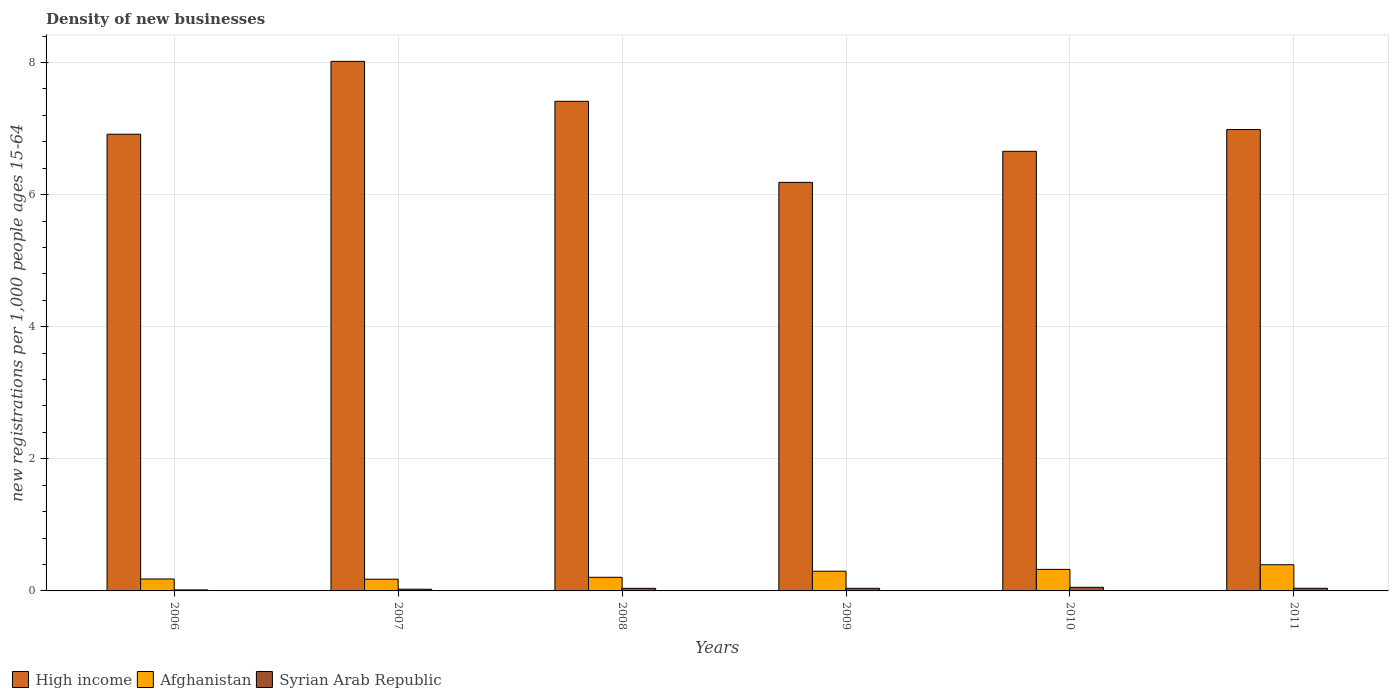How many different coloured bars are there?
Your response must be concise. 3. Are the number of bars on each tick of the X-axis equal?
Make the answer very short. Yes. How many bars are there on the 5th tick from the left?
Offer a terse response. 3. How many bars are there on the 5th tick from the right?
Offer a very short reply. 3. What is the label of the 2nd group of bars from the left?
Provide a short and direct response. 2007. In how many cases, is the number of bars for a given year not equal to the number of legend labels?
Keep it short and to the point. 0. What is the number of new registrations in High income in 2010?
Provide a succinct answer. 6.66. Across all years, what is the maximum number of new registrations in High income?
Give a very brief answer. 8.02. Across all years, what is the minimum number of new registrations in High income?
Keep it short and to the point. 6.19. In which year was the number of new registrations in Afghanistan minimum?
Provide a succinct answer. 2007. What is the total number of new registrations in High income in the graph?
Give a very brief answer. 42.17. What is the difference between the number of new registrations in High income in 2007 and that in 2011?
Make the answer very short. 1.03. What is the difference between the number of new registrations in Afghanistan in 2011 and the number of new registrations in High income in 2010?
Offer a very short reply. -6.26. What is the average number of new registrations in Syrian Arab Republic per year?
Offer a very short reply. 0.04. In the year 2010, what is the difference between the number of new registrations in Syrian Arab Republic and number of new registrations in Afghanistan?
Provide a succinct answer. -0.27. What is the ratio of the number of new registrations in Syrian Arab Republic in 2008 to that in 2009?
Ensure brevity in your answer.  0.98. Is the difference between the number of new registrations in Syrian Arab Republic in 2006 and 2010 greater than the difference between the number of new registrations in Afghanistan in 2006 and 2010?
Offer a terse response. Yes. What is the difference between the highest and the second highest number of new registrations in Afghanistan?
Give a very brief answer. 0.07. What is the difference between the highest and the lowest number of new registrations in High income?
Offer a very short reply. 1.83. In how many years, is the number of new registrations in Afghanistan greater than the average number of new registrations in Afghanistan taken over all years?
Provide a succinct answer. 3. What does the 1st bar from the left in 2011 represents?
Provide a succinct answer. High income. What does the 3rd bar from the right in 2007 represents?
Your answer should be compact. High income. Is it the case that in every year, the sum of the number of new registrations in High income and number of new registrations in Afghanistan is greater than the number of new registrations in Syrian Arab Republic?
Your response must be concise. Yes. How many bars are there?
Your response must be concise. 18. Are the values on the major ticks of Y-axis written in scientific E-notation?
Provide a short and direct response. No. Where does the legend appear in the graph?
Offer a very short reply. Bottom left. How many legend labels are there?
Your response must be concise. 3. What is the title of the graph?
Provide a short and direct response. Density of new businesses. What is the label or title of the X-axis?
Offer a terse response. Years. What is the label or title of the Y-axis?
Offer a very short reply. New registrations per 1,0 people ages 15-64. What is the new registrations per 1,000 people ages 15-64 of High income in 2006?
Provide a succinct answer. 6.91. What is the new registrations per 1,000 people ages 15-64 in Afghanistan in 2006?
Ensure brevity in your answer.  0.18. What is the new registrations per 1,000 people ages 15-64 in Syrian Arab Republic in 2006?
Your answer should be very brief. 0.02. What is the new registrations per 1,000 people ages 15-64 in High income in 2007?
Your answer should be very brief. 8.02. What is the new registrations per 1,000 people ages 15-64 of Afghanistan in 2007?
Your response must be concise. 0.18. What is the new registrations per 1,000 people ages 15-64 in Syrian Arab Republic in 2007?
Offer a very short reply. 0.03. What is the new registrations per 1,000 people ages 15-64 in High income in 2008?
Make the answer very short. 7.41. What is the new registrations per 1,000 people ages 15-64 in Afghanistan in 2008?
Offer a terse response. 0.21. What is the new registrations per 1,000 people ages 15-64 of Syrian Arab Republic in 2008?
Your answer should be compact. 0.04. What is the new registrations per 1,000 people ages 15-64 of High income in 2009?
Your answer should be very brief. 6.19. What is the new registrations per 1,000 people ages 15-64 in Afghanistan in 2009?
Give a very brief answer. 0.3. What is the new registrations per 1,000 people ages 15-64 in Syrian Arab Republic in 2009?
Your answer should be compact. 0.04. What is the new registrations per 1,000 people ages 15-64 of High income in 2010?
Make the answer very short. 6.66. What is the new registrations per 1,000 people ages 15-64 of Afghanistan in 2010?
Your answer should be compact. 0.33. What is the new registrations per 1,000 people ages 15-64 in Syrian Arab Republic in 2010?
Offer a very short reply. 0.05. What is the new registrations per 1,000 people ages 15-64 of High income in 2011?
Offer a very short reply. 6.99. What is the new registrations per 1,000 people ages 15-64 in Afghanistan in 2011?
Your answer should be compact. 0.4. Across all years, what is the maximum new registrations per 1,000 people ages 15-64 of High income?
Offer a terse response. 8.02. Across all years, what is the maximum new registrations per 1,000 people ages 15-64 in Afghanistan?
Keep it short and to the point. 0.4. Across all years, what is the maximum new registrations per 1,000 people ages 15-64 of Syrian Arab Republic?
Provide a succinct answer. 0.05. Across all years, what is the minimum new registrations per 1,000 people ages 15-64 in High income?
Your response must be concise. 6.19. Across all years, what is the minimum new registrations per 1,000 people ages 15-64 in Afghanistan?
Ensure brevity in your answer.  0.18. Across all years, what is the minimum new registrations per 1,000 people ages 15-64 in Syrian Arab Republic?
Make the answer very short. 0.02. What is the total new registrations per 1,000 people ages 15-64 of High income in the graph?
Give a very brief answer. 42.17. What is the total new registrations per 1,000 people ages 15-64 of Afghanistan in the graph?
Provide a short and direct response. 1.59. What is the total new registrations per 1,000 people ages 15-64 of Syrian Arab Republic in the graph?
Provide a succinct answer. 0.21. What is the difference between the new registrations per 1,000 people ages 15-64 in High income in 2006 and that in 2007?
Provide a short and direct response. -1.1. What is the difference between the new registrations per 1,000 people ages 15-64 in Afghanistan in 2006 and that in 2007?
Give a very brief answer. 0. What is the difference between the new registrations per 1,000 people ages 15-64 of Syrian Arab Republic in 2006 and that in 2007?
Offer a very short reply. -0.01. What is the difference between the new registrations per 1,000 people ages 15-64 of High income in 2006 and that in 2008?
Your response must be concise. -0.5. What is the difference between the new registrations per 1,000 people ages 15-64 in Afghanistan in 2006 and that in 2008?
Your answer should be compact. -0.03. What is the difference between the new registrations per 1,000 people ages 15-64 of Syrian Arab Republic in 2006 and that in 2008?
Make the answer very short. -0.02. What is the difference between the new registrations per 1,000 people ages 15-64 in High income in 2006 and that in 2009?
Keep it short and to the point. 0.73. What is the difference between the new registrations per 1,000 people ages 15-64 of Afghanistan in 2006 and that in 2009?
Make the answer very short. -0.12. What is the difference between the new registrations per 1,000 people ages 15-64 of Syrian Arab Republic in 2006 and that in 2009?
Provide a short and direct response. -0.02. What is the difference between the new registrations per 1,000 people ages 15-64 in High income in 2006 and that in 2010?
Ensure brevity in your answer.  0.26. What is the difference between the new registrations per 1,000 people ages 15-64 in Afghanistan in 2006 and that in 2010?
Provide a short and direct response. -0.15. What is the difference between the new registrations per 1,000 people ages 15-64 in Syrian Arab Republic in 2006 and that in 2010?
Provide a short and direct response. -0.04. What is the difference between the new registrations per 1,000 people ages 15-64 in High income in 2006 and that in 2011?
Your answer should be compact. -0.07. What is the difference between the new registrations per 1,000 people ages 15-64 in Afghanistan in 2006 and that in 2011?
Ensure brevity in your answer.  -0.22. What is the difference between the new registrations per 1,000 people ages 15-64 in Syrian Arab Republic in 2006 and that in 2011?
Offer a terse response. -0.02. What is the difference between the new registrations per 1,000 people ages 15-64 of High income in 2007 and that in 2008?
Give a very brief answer. 0.6. What is the difference between the new registrations per 1,000 people ages 15-64 of Afghanistan in 2007 and that in 2008?
Your answer should be very brief. -0.03. What is the difference between the new registrations per 1,000 people ages 15-64 of Syrian Arab Republic in 2007 and that in 2008?
Offer a terse response. -0.01. What is the difference between the new registrations per 1,000 people ages 15-64 in High income in 2007 and that in 2009?
Give a very brief answer. 1.83. What is the difference between the new registrations per 1,000 people ages 15-64 in Afghanistan in 2007 and that in 2009?
Ensure brevity in your answer.  -0.12. What is the difference between the new registrations per 1,000 people ages 15-64 in Syrian Arab Republic in 2007 and that in 2009?
Your answer should be very brief. -0.01. What is the difference between the new registrations per 1,000 people ages 15-64 of High income in 2007 and that in 2010?
Ensure brevity in your answer.  1.36. What is the difference between the new registrations per 1,000 people ages 15-64 of Afghanistan in 2007 and that in 2010?
Your answer should be very brief. -0.15. What is the difference between the new registrations per 1,000 people ages 15-64 in Syrian Arab Republic in 2007 and that in 2010?
Ensure brevity in your answer.  -0.03. What is the difference between the new registrations per 1,000 people ages 15-64 of High income in 2007 and that in 2011?
Keep it short and to the point. 1.03. What is the difference between the new registrations per 1,000 people ages 15-64 of Afghanistan in 2007 and that in 2011?
Provide a short and direct response. -0.22. What is the difference between the new registrations per 1,000 people ages 15-64 of Syrian Arab Republic in 2007 and that in 2011?
Give a very brief answer. -0.01. What is the difference between the new registrations per 1,000 people ages 15-64 of High income in 2008 and that in 2009?
Make the answer very short. 1.23. What is the difference between the new registrations per 1,000 people ages 15-64 of Afghanistan in 2008 and that in 2009?
Your answer should be compact. -0.09. What is the difference between the new registrations per 1,000 people ages 15-64 of Syrian Arab Republic in 2008 and that in 2009?
Offer a terse response. -0. What is the difference between the new registrations per 1,000 people ages 15-64 in High income in 2008 and that in 2010?
Provide a short and direct response. 0.76. What is the difference between the new registrations per 1,000 people ages 15-64 in Afghanistan in 2008 and that in 2010?
Keep it short and to the point. -0.12. What is the difference between the new registrations per 1,000 people ages 15-64 of Syrian Arab Republic in 2008 and that in 2010?
Offer a terse response. -0.02. What is the difference between the new registrations per 1,000 people ages 15-64 of High income in 2008 and that in 2011?
Provide a succinct answer. 0.43. What is the difference between the new registrations per 1,000 people ages 15-64 of Afghanistan in 2008 and that in 2011?
Provide a succinct answer. -0.19. What is the difference between the new registrations per 1,000 people ages 15-64 of Syrian Arab Republic in 2008 and that in 2011?
Your response must be concise. -0. What is the difference between the new registrations per 1,000 people ages 15-64 of High income in 2009 and that in 2010?
Ensure brevity in your answer.  -0.47. What is the difference between the new registrations per 1,000 people ages 15-64 of Afghanistan in 2009 and that in 2010?
Your response must be concise. -0.03. What is the difference between the new registrations per 1,000 people ages 15-64 of Syrian Arab Republic in 2009 and that in 2010?
Ensure brevity in your answer.  -0.02. What is the difference between the new registrations per 1,000 people ages 15-64 of High income in 2009 and that in 2011?
Give a very brief answer. -0.8. What is the difference between the new registrations per 1,000 people ages 15-64 of Afghanistan in 2009 and that in 2011?
Give a very brief answer. -0.1. What is the difference between the new registrations per 1,000 people ages 15-64 in Syrian Arab Republic in 2009 and that in 2011?
Offer a terse response. -0. What is the difference between the new registrations per 1,000 people ages 15-64 of High income in 2010 and that in 2011?
Keep it short and to the point. -0.33. What is the difference between the new registrations per 1,000 people ages 15-64 of Afghanistan in 2010 and that in 2011?
Keep it short and to the point. -0.07. What is the difference between the new registrations per 1,000 people ages 15-64 of Syrian Arab Republic in 2010 and that in 2011?
Your answer should be very brief. 0.01. What is the difference between the new registrations per 1,000 people ages 15-64 in High income in 2006 and the new registrations per 1,000 people ages 15-64 in Afghanistan in 2007?
Give a very brief answer. 6.74. What is the difference between the new registrations per 1,000 people ages 15-64 in High income in 2006 and the new registrations per 1,000 people ages 15-64 in Syrian Arab Republic in 2007?
Keep it short and to the point. 6.89. What is the difference between the new registrations per 1,000 people ages 15-64 in Afghanistan in 2006 and the new registrations per 1,000 people ages 15-64 in Syrian Arab Republic in 2007?
Offer a terse response. 0.15. What is the difference between the new registrations per 1,000 people ages 15-64 in High income in 2006 and the new registrations per 1,000 people ages 15-64 in Afghanistan in 2008?
Offer a terse response. 6.71. What is the difference between the new registrations per 1,000 people ages 15-64 of High income in 2006 and the new registrations per 1,000 people ages 15-64 of Syrian Arab Republic in 2008?
Give a very brief answer. 6.88. What is the difference between the new registrations per 1,000 people ages 15-64 in Afghanistan in 2006 and the new registrations per 1,000 people ages 15-64 in Syrian Arab Republic in 2008?
Give a very brief answer. 0.14. What is the difference between the new registrations per 1,000 people ages 15-64 in High income in 2006 and the new registrations per 1,000 people ages 15-64 in Afghanistan in 2009?
Provide a short and direct response. 6.62. What is the difference between the new registrations per 1,000 people ages 15-64 of High income in 2006 and the new registrations per 1,000 people ages 15-64 of Syrian Arab Republic in 2009?
Ensure brevity in your answer.  6.88. What is the difference between the new registrations per 1,000 people ages 15-64 of Afghanistan in 2006 and the new registrations per 1,000 people ages 15-64 of Syrian Arab Republic in 2009?
Give a very brief answer. 0.14. What is the difference between the new registrations per 1,000 people ages 15-64 in High income in 2006 and the new registrations per 1,000 people ages 15-64 in Afghanistan in 2010?
Give a very brief answer. 6.59. What is the difference between the new registrations per 1,000 people ages 15-64 of High income in 2006 and the new registrations per 1,000 people ages 15-64 of Syrian Arab Republic in 2010?
Your answer should be very brief. 6.86. What is the difference between the new registrations per 1,000 people ages 15-64 of Afghanistan in 2006 and the new registrations per 1,000 people ages 15-64 of Syrian Arab Republic in 2010?
Offer a very short reply. 0.13. What is the difference between the new registrations per 1,000 people ages 15-64 of High income in 2006 and the new registrations per 1,000 people ages 15-64 of Afghanistan in 2011?
Your response must be concise. 6.52. What is the difference between the new registrations per 1,000 people ages 15-64 in High income in 2006 and the new registrations per 1,000 people ages 15-64 in Syrian Arab Republic in 2011?
Provide a short and direct response. 6.87. What is the difference between the new registrations per 1,000 people ages 15-64 in Afghanistan in 2006 and the new registrations per 1,000 people ages 15-64 in Syrian Arab Republic in 2011?
Your response must be concise. 0.14. What is the difference between the new registrations per 1,000 people ages 15-64 of High income in 2007 and the new registrations per 1,000 people ages 15-64 of Afghanistan in 2008?
Provide a succinct answer. 7.81. What is the difference between the new registrations per 1,000 people ages 15-64 in High income in 2007 and the new registrations per 1,000 people ages 15-64 in Syrian Arab Republic in 2008?
Your answer should be compact. 7.98. What is the difference between the new registrations per 1,000 people ages 15-64 in Afghanistan in 2007 and the new registrations per 1,000 people ages 15-64 in Syrian Arab Republic in 2008?
Your answer should be very brief. 0.14. What is the difference between the new registrations per 1,000 people ages 15-64 of High income in 2007 and the new registrations per 1,000 people ages 15-64 of Afghanistan in 2009?
Your answer should be compact. 7.72. What is the difference between the new registrations per 1,000 people ages 15-64 of High income in 2007 and the new registrations per 1,000 people ages 15-64 of Syrian Arab Republic in 2009?
Offer a very short reply. 7.98. What is the difference between the new registrations per 1,000 people ages 15-64 of Afghanistan in 2007 and the new registrations per 1,000 people ages 15-64 of Syrian Arab Republic in 2009?
Your answer should be very brief. 0.14. What is the difference between the new registrations per 1,000 people ages 15-64 of High income in 2007 and the new registrations per 1,000 people ages 15-64 of Afghanistan in 2010?
Ensure brevity in your answer.  7.69. What is the difference between the new registrations per 1,000 people ages 15-64 in High income in 2007 and the new registrations per 1,000 people ages 15-64 in Syrian Arab Republic in 2010?
Your answer should be compact. 7.96. What is the difference between the new registrations per 1,000 people ages 15-64 in Afghanistan in 2007 and the new registrations per 1,000 people ages 15-64 in Syrian Arab Republic in 2010?
Keep it short and to the point. 0.12. What is the difference between the new registrations per 1,000 people ages 15-64 of High income in 2007 and the new registrations per 1,000 people ages 15-64 of Afghanistan in 2011?
Your answer should be compact. 7.62. What is the difference between the new registrations per 1,000 people ages 15-64 in High income in 2007 and the new registrations per 1,000 people ages 15-64 in Syrian Arab Republic in 2011?
Your answer should be very brief. 7.98. What is the difference between the new registrations per 1,000 people ages 15-64 in Afghanistan in 2007 and the new registrations per 1,000 people ages 15-64 in Syrian Arab Republic in 2011?
Offer a very short reply. 0.14. What is the difference between the new registrations per 1,000 people ages 15-64 of High income in 2008 and the new registrations per 1,000 people ages 15-64 of Afghanistan in 2009?
Offer a terse response. 7.11. What is the difference between the new registrations per 1,000 people ages 15-64 in High income in 2008 and the new registrations per 1,000 people ages 15-64 in Syrian Arab Republic in 2009?
Provide a short and direct response. 7.37. What is the difference between the new registrations per 1,000 people ages 15-64 of Afghanistan in 2008 and the new registrations per 1,000 people ages 15-64 of Syrian Arab Republic in 2009?
Provide a short and direct response. 0.17. What is the difference between the new registrations per 1,000 people ages 15-64 in High income in 2008 and the new registrations per 1,000 people ages 15-64 in Afghanistan in 2010?
Offer a very short reply. 7.09. What is the difference between the new registrations per 1,000 people ages 15-64 in High income in 2008 and the new registrations per 1,000 people ages 15-64 in Syrian Arab Republic in 2010?
Ensure brevity in your answer.  7.36. What is the difference between the new registrations per 1,000 people ages 15-64 of Afghanistan in 2008 and the new registrations per 1,000 people ages 15-64 of Syrian Arab Republic in 2010?
Keep it short and to the point. 0.15. What is the difference between the new registrations per 1,000 people ages 15-64 in High income in 2008 and the new registrations per 1,000 people ages 15-64 in Afghanistan in 2011?
Your response must be concise. 7.02. What is the difference between the new registrations per 1,000 people ages 15-64 of High income in 2008 and the new registrations per 1,000 people ages 15-64 of Syrian Arab Republic in 2011?
Your response must be concise. 7.37. What is the difference between the new registrations per 1,000 people ages 15-64 in Afghanistan in 2008 and the new registrations per 1,000 people ages 15-64 in Syrian Arab Republic in 2011?
Give a very brief answer. 0.17. What is the difference between the new registrations per 1,000 people ages 15-64 in High income in 2009 and the new registrations per 1,000 people ages 15-64 in Afghanistan in 2010?
Your answer should be very brief. 5.86. What is the difference between the new registrations per 1,000 people ages 15-64 in High income in 2009 and the new registrations per 1,000 people ages 15-64 in Syrian Arab Republic in 2010?
Your response must be concise. 6.13. What is the difference between the new registrations per 1,000 people ages 15-64 of Afghanistan in 2009 and the new registrations per 1,000 people ages 15-64 of Syrian Arab Republic in 2010?
Make the answer very short. 0.24. What is the difference between the new registrations per 1,000 people ages 15-64 in High income in 2009 and the new registrations per 1,000 people ages 15-64 in Afghanistan in 2011?
Your response must be concise. 5.79. What is the difference between the new registrations per 1,000 people ages 15-64 in High income in 2009 and the new registrations per 1,000 people ages 15-64 in Syrian Arab Republic in 2011?
Provide a succinct answer. 6.15. What is the difference between the new registrations per 1,000 people ages 15-64 of Afghanistan in 2009 and the new registrations per 1,000 people ages 15-64 of Syrian Arab Republic in 2011?
Offer a terse response. 0.26. What is the difference between the new registrations per 1,000 people ages 15-64 in High income in 2010 and the new registrations per 1,000 people ages 15-64 in Afghanistan in 2011?
Keep it short and to the point. 6.26. What is the difference between the new registrations per 1,000 people ages 15-64 in High income in 2010 and the new registrations per 1,000 people ages 15-64 in Syrian Arab Republic in 2011?
Your answer should be very brief. 6.62. What is the difference between the new registrations per 1,000 people ages 15-64 in Afghanistan in 2010 and the new registrations per 1,000 people ages 15-64 in Syrian Arab Republic in 2011?
Your answer should be very brief. 0.29. What is the average new registrations per 1,000 people ages 15-64 of High income per year?
Provide a succinct answer. 7.03. What is the average new registrations per 1,000 people ages 15-64 of Afghanistan per year?
Your answer should be very brief. 0.26. What is the average new registrations per 1,000 people ages 15-64 of Syrian Arab Republic per year?
Give a very brief answer. 0.04. In the year 2006, what is the difference between the new registrations per 1,000 people ages 15-64 in High income and new registrations per 1,000 people ages 15-64 in Afghanistan?
Ensure brevity in your answer.  6.73. In the year 2006, what is the difference between the new registrations per 1,000 people ages 15-64 in High income and new registrations per 1,000 people ages 15-64 in Syrian Arab Republic?
Ensure brevity in your answer.  6.9. In the year 2006, what is the difference between the new registrations per 1,000 people ages 15-64 of Afghanistan and new registrations per 1,000 people ages 15-64 of Syrian Arab Republic?
Offer a terse response. 0.17. In the year 2007, what is the difference between the new registrations per 1,000 people ages 15-64 in High income and new registrations per 1,000 people ages 15-64 in Afghanistan?
Make the answer very short. 7.84. In the year 2007, what is the difference between the new registrations per 1,000 people ages 15-64 in High income and new registrations per 1,000 people ages 15-64 in Syrian Arab Republic?
Your answer should be compact. 7.99. In the year 2007, what is the difference between the new registrations per 1,000 people ages 15-64 of Afghanistan and new registrations per 1,000 people ages 15-64 of Syrian Arab Republic?
Your answer should be compact. 0.15. In the year 2008, what is the difference between the new registrations per 1,000 people ages 15-64 of High income and new registrations per 1,000 people ages 15-64 of Afghanistan?
Your response must be concise. 7.21. In the year 2008, what is the difference between the new registrations per 1,000 people ages 15-64 in High income and new registrations per 1,000 people ages 15-64 in Syrian Arab Republic?
Make the answer very short. 7.37. In the year 2008, what is the difference between the new registrations per 1,000 people ages 15-64 in Afghanistan and new registrations per 1,000 people ages 15-64 in Syrian Arab Republic?
Provide a succinct answer. 0.17. In the year 2009, what is the difference between the new registrations per 1,000 people ages 15-64 of High income and new registrations per 1,000 people ages 15-64 of Afghanistan?
Your answer should be compact. 5.89. In the year 2009, what is the difference between the new registrations per 1,000 people ages 15-64 of High income and new registrations per 1,000 people ages 15-64 of Syrian Arab Republic?
Offer a terse response. 6.15. In the year 2009, what is the difference between the new registrations per 1,000 people ages 15-64 of Afghanistan and new registrations per 1,000 people ages 15-64 of Syrian Arab Republic?
Give a very brief answer. 0.26. In the year 2010, what is the difference between the new registrations per 1,000 people ages 15-64 of High income and new registrations per 1,000 people ages 15-64 of Afghanistan?
Provide a succinct answer. 6.33. In the year 2010, what is the difference between the new registrations per 1,000 people ages 15-64 in High income and new registrations per 1,000 people ages 15-64 in Syrian Arab Republic?
Make the answer very short. 6.6. In the year 2010, what is the difference between the new registrations per 1,000 people ages 15-64 of Afghanistan and new registrations per 1,000 people ages 15-64 of Syrian Arab Republic?
Keep it short and to the point. 0.27. In the year 2011, what is the difference between the new registrations per 1,000 people ages 15-64 of High income and new registrations per 1,000 people ages 15-64 of Afghanistan?
Offer a terse response. 6.59. In the year 2011, what is the difference between the new registrations per 1,000 people ages 15-64 in High income and new registrations per 1,000 people ages 15-64 in Syrian Arab Republic?
Ensure brevity in your answer.  6.95. In the year 2011, what is the difference between the new registrations per 1,000 people ages 15-64 in Afghanistan and new registrations per 1,000 people ages 15-64 in Syrian Arab Republic?
Keep it short and to the point. 0.36. What is the ratio of the new registrations per 1,000 people ages 15-64 in High income in 2006 to that in 2007?
Your answer should be very brief. 0.86. What is the ratio of the new registrations per 1,000 people ages 15-64 in Afghanistan in 2006 to that in 2007?
Keep it short and to the point. 1.02. What is the ratio of the new registrations per 1,000 people ages 15-64 of Syrian Arab Republic in 2006 to that in 2007?
Make the answer very short. 0.61. What is the ratio of the new registrations per 1,000 people ages 15-64 of High income in 2006 to that in 2008?
Provide a succinct answer. 0.93. What is the ratio of the new registrations per 1,000 people ages 15-64 of Afghanistan in 2006 to that in 2008?
Your answer should be compact. 0.87. What is the ratio of the new registrations per 1,000 people ages 15-64 of Syrian Arab Republic in 2006 to that in 2008?
Provide a succinct answer. 0.4. What is the ratio of the new registrations per 1,000 people ages 15-64 of High income in 2006 to that in 2009?
Provide a short and direct response. 1.12. What is the ratio of the new registrations per 1,000 people ages 15-64 of Afghanistan in 2006 to that in 2009?
Offer a very short reply. 0.61. What is the ratio of the new registrations per 1,000 people ages 15-64 in Syrian Arab Republic in 2006 to that in 2009?
Give a very brief answer. 0.39. What is the ratio of the new registrations per 1,000 people ages 15-64 in High income in 2006 to that in 2010?
Your answer should be compact. 1.04. What is the ratio of the new registrations per 1,000 people ages 15-64 of Afghanistan in 2006 to that in 2010?
Provide a short and direct response. 0.55. What is the ratio of the new registrations per 1,000 people ages 15-64 of Syrian Arab Republic in 2006 to that in 2010?
Keep it short and to the point. 0.28. What is the ratio of the new registrations per 1,000 people ages 15-64 of High income in 2006 to that in 2011?
Your answer should be very brief. 0.99. What is the ratio of the new registrations per 1,000 people ages 15-64 in Afghanistan in 2006 to that in 2011?
Your response must be concise. 0.46. What is the ratio of the new registrations per 1,000 people ages 15-64 in Syrian Arab Republic in 2006 to that in 2011?
Your response must be concise. 0.39. What is the ratio of the new registrations per 1,000 people ages 15-64 of High income in 2007 to that in 2008?
Your answer should be compact. 1.08. What is the ratio of the new registrations per 1,000 people ages 15-64 of Afghanistan in 2007 to that in 2008?
Offer a very short reply. 0.86. What is the ratio of the new registrations per 1,000 people ages 15-64 of Syrian Arab Republic in 2007 to that in 2008?
Make the answer very short. 0.66. What is the ratio of the new registrations per 1,000 people ages 15-64 in High income in 2007 to that in 2009?
Make the answer very short. 1.3. What is the ratio of the new registrations per 1,000 people ages 15-64 of Afghanistan in 2007 to that in 2009?
Keep it short and to the point. 0.59. What is the ratio of the new registrations per 1,000 people ages 15-64 in Syrian Arab Republic in 2007 to that in 2009?
Your answer should be compact. 0.65. What is the ratio of the new registrations per 1,000 people ages 15-64 of High income in 2007 to that in 2010?
Provide a succinct answer. 1.2. What is the ratio of the new registrations per 1,000 people ages 15-64 of Afghanistan in 2007 to that in 2010?
Provide a short and direct response. 0.54. What is the ratio of the new registrations per 1,000 people ages 15-64 of Syrian Arab Republic in 2007 to that in 2010?
Ensure brevity in your answer.  0.47. What is the ratio of the new registrations per 1,000 people ages 15-64 of High income in 2007 to that in 2011?
Your answer should be compact. 1.15. What is the ratio of the new registrations per 1,000 people ages 15-64 of Afghanistan in 2007 to that in 2011?
Keep it short and to the point. 0.45. What is the ratio of the new registrations per 1,000 people ages 15-64 in Syrian Arab Republic in 2007 to that in 2011?
Your answer should be compact. 0.64. What is the ratio of the new registrations per 1,000 people ages 15-64 in High income in 2008 to that in 2009?
Offer a terse response. 1.2. What is the ratio of the new registrations per 1,000 people ages 15-64 of Afghanistan in 2008 to that in 2009?
Your answer should be very brief. 0.69. What is the ratio of the new registrations per 1,000 people ages 15-64 in Syrian Arab Republic in 2008 to that in 2009?
Offer a terse response. 0.98. What is the ratio of the new registrations per 1,000 people ages 15-64 of High income in 2008 to that in 2010?
Your answer should be very brief. 1.11. What is the ratio of the new registrations per 1,000 people ages 15-64 of Afghanistan in 2008 to that in 2010?
Your answer should be compact. 0.63. What is the ratio of the new registrations per 1,000 people ages 15-64 in Syrian Arab Republic in 2008 to that in 2010?
Ensure brevity in your answer.  0.71. What is the ratio of the new registrations per 1,000 people ages 15-64 in High income in 2008 to that in 2011?
Give a very brief answer. 1.06. What is the ratio of the new registrations per 1,000 people ages 15-64 of Afghanistan in 2008 to that in 2011?
Give a very brief answer. 0.52. What is the ratio of the new registrations per 1,000 people ages 15-64 in Syrian Arab Republic in 2008 to that in 2011?
Provide a succinct answer. 0.97. What is the ratio of the new registrations per 1,000 people ages 15-64 in High income in 2009 to that in 2010?
Offer a terse response. 0.93. What is the ratio of the new registrations per 1,000 people ages 15-64 of Afghanistan in 2009 to that in 2010?
Make the answer very short. 0.92. What is the ratio of the new registrations per 1,000 people ages 15-64 of Syrian Arab Republic in 2009 to that in 2010?
Your answer should be very brief. 0.72. What is the ratio of the new registrations per 1,000 people ages 15-64 in High income in 2009 to that in 2011?
Your answer should be very brief. 0.89. What is the ratio of the new registrations per 1,000 people ages 15-64 of Afghanistan in 2009 to that in 2011?
Provide a succinct answer. 0.75. What is the ratio of the new registrations per 1,000 people ages 15-64 of High income in 2010 to that in 2011?
Give a very brief answer. 0.95. What is the ratio of the new registrations per 1,000 people ages 15-64 in Afghanistan in 2010 to that in 2011?
Make the answer very short. 0.82. What is the ratio of the new registrations per 1,000 people ages 15-64 of Syrian Arab Republic in 2010 to that in 2011?
Provide a short and direct response. 1.37. What is the difference between the highest and the second highest new registrations per 1,000 people ages 15-64 in High income?
Offer a very short reply. 0.6. What is the difference between the highest and the second highest new registrations per 1,000 people ages 15-64 in Afghanistan?
Offer a terse response. 0.07. What is the difference between the highest and the second highest new registrations per 1,000 people ages 15-64 in Syrian Arab Republic?
Offer a terse response. 0.01. What is the difference between the highest and the lowest new registrations per 1,000 people ages 15-64 in High income?
Your response must be concise. 1.83. What is the difference between the highest and the lowest new registrations per 1,000 people ages 15-64 of Afghanistan?
Give a very brief answer. 0.22. What is the difference between the highest and the lowest new registrations per 1,000 people ages 15-64 in Syrian Arab Republic?
Your answer should be compact. 0.04. 